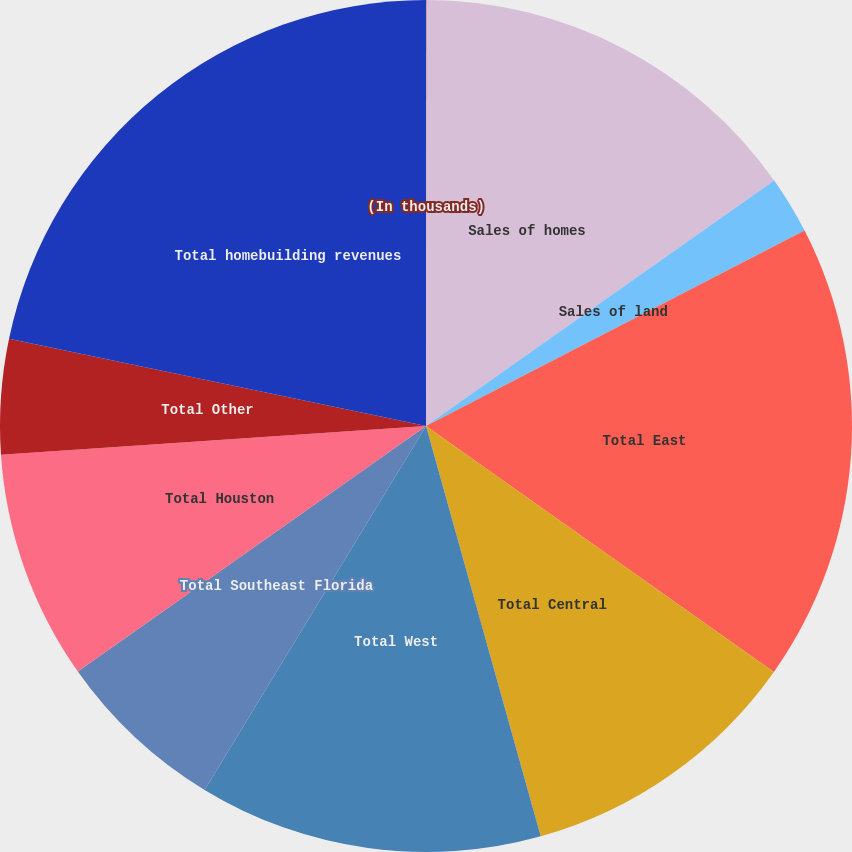Convert chart. <chart><loc_0><loc_0><loc_500><loc_500><pie_chart><fcel>(In thousands)<fcel>Sales of homes<fcel>Sales of land<fcel>Total East<fcel>Total Central<fcel>Total West<fcel>Total Southeast Florida<fcel>Total Houston<fcel>Total Other<fcel>Total homebuilding revenues<nl><fcel>0.02%<fcel>15.21%<fcel>2.19%<fcel>17.38%<fcel>10.87%<fcel>13.04%<fcel>6.53%<fcel>8.7%<fcel>4.36%<fcel>21.72%<nl></chart> 